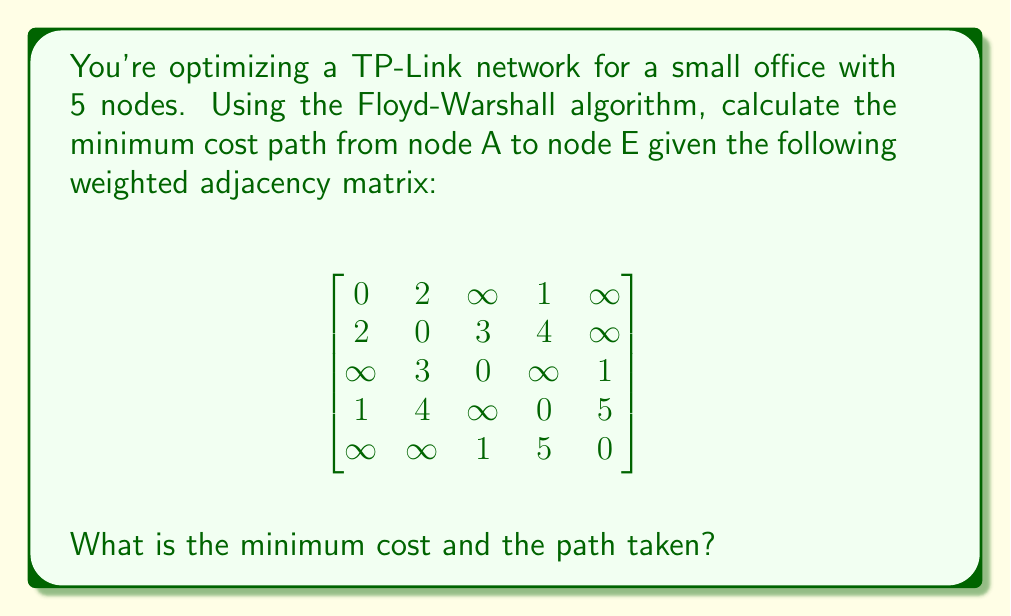Show me your answer to this math problem. Let's apply the Floyd-Warshall algorithm to find the shortest path between all pairs of nodes:

1) Initialize the distance matrix D with the given adjacency matrix.

2) For each intermediate node k (0 to 4):
   For each pair of nodes (i, j):
     Update D[i][j] = min(D[i][j], D[i][k] + D[k][j])

3) After all iterations, the final distance matrix D is:

$$
D = \begin{bmatrix}
0 & 2 & 5 & 1 & 6 \\
2 & 0 & 3 & 3 & 4 \\
5 & 3 & 0 & 6 & 1 \\
1 & 3 & 6 & 0 & 5 \\
6 & 4 & 1 & 5 & 0
\end{bmatrix}
$$

4) The minimum cost from A to E is D[0][4] = 6.

5) To find the path:
   - Start at A (node 0)
   - Check if there's an intermediate node that gives this cost:
     D[0][1] + D[1][4] = 2 + 4 = 6
   - So the path goes through B (node 1)
   - From B to E, it goes directly as D[1][4] = 4

Therefore, the path is A -> B -> E with a total cost of 6.
Answer: Cost: 6, Path: A -> B -> E 